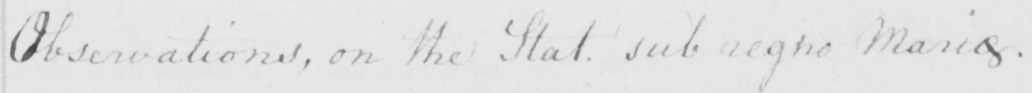What does this handwritten line say? Observations , on the Stat . sub regno Mariae  . 